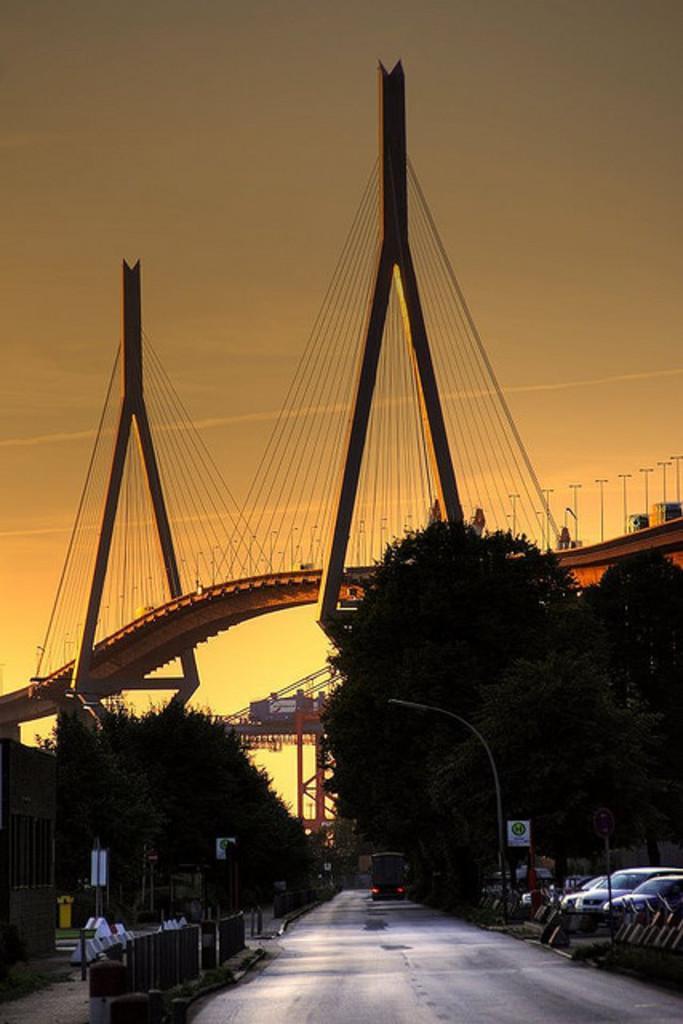In one or two sentences, can you explain what this image depicts? At the bottom of this image, there is a road, on which there is a vehicle. On both sides of this road, there are trees and poles. On the left side, there is a fence. On the right side, there are vehicles and a fence. In the background, there is a bridge, on which there are poles and there are clouds in the sky. 